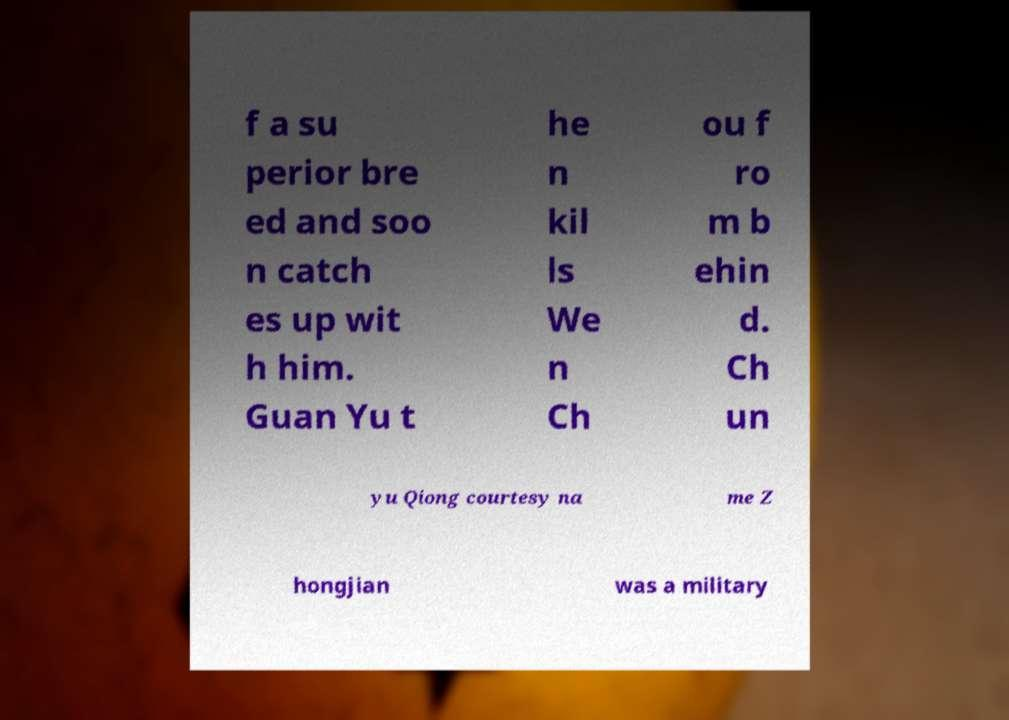Could you assist in decoding the text presented in this image and type it out clearly? f a su perior bre ed and soo n catch es up wit h him. Guan Yu t he n kil ls We n Ch ou f ro m b ehin d. Ch un yu Qiong courtesy na me Z hongjian was a military 